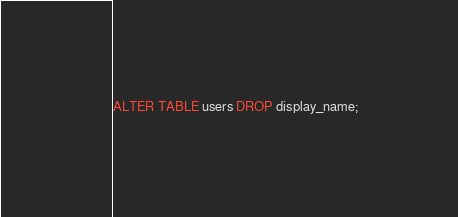Convert code to text. <code><loc_0><loc_0><loc_500><loc_500><_SQL_>ALTER TABLE users DROP display_name;
</code> 